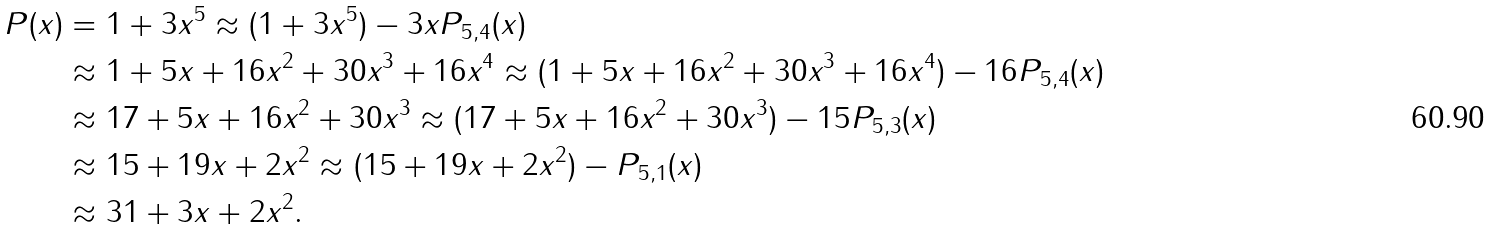<formula> <loc_0><loc_0><loc_500><loc_500>P ( x ) & = 1 + 3 x ^ { 5 } \approx ( 1 + 3 x ^ { 5 } ) - 3 x P _ { 5 , 4 } ( x ) \\ & \approx 1 + 5 x + 1 6 x ^ { 2 } + 3 0 x ^ { 3 } + 1 6 x ^ { 4 } \approx ( 1 + 5 x + 1 6 x ^ { 2 } + 3 0 x ^ { 3 } + 1 6 x ^ { 4 } ) - 1 6 P _ { 5 , 4 } ( x ) \\ & \approx 1 7 + 5 x + 1 6 x ^ { 2 } + 3 0 x ^ { 3 } \approx ( 1 7 + 5 x + 1 6 x ^ { 2 } + 3 0 x ^ { 3 } ) - 1 5 P _ { 5 , 3 } ( x ) \\ & \approx 1 5 + 1 9 x + 2 x ^ { 2 } \approx ( 1 5 + 1 9 x + 2 x ^ { 2 } ) - P _ { 5 , 1 } ( x ) \\ & \approx 3 1 + 3 x + 2 x ^ { 2 } .</formula> 